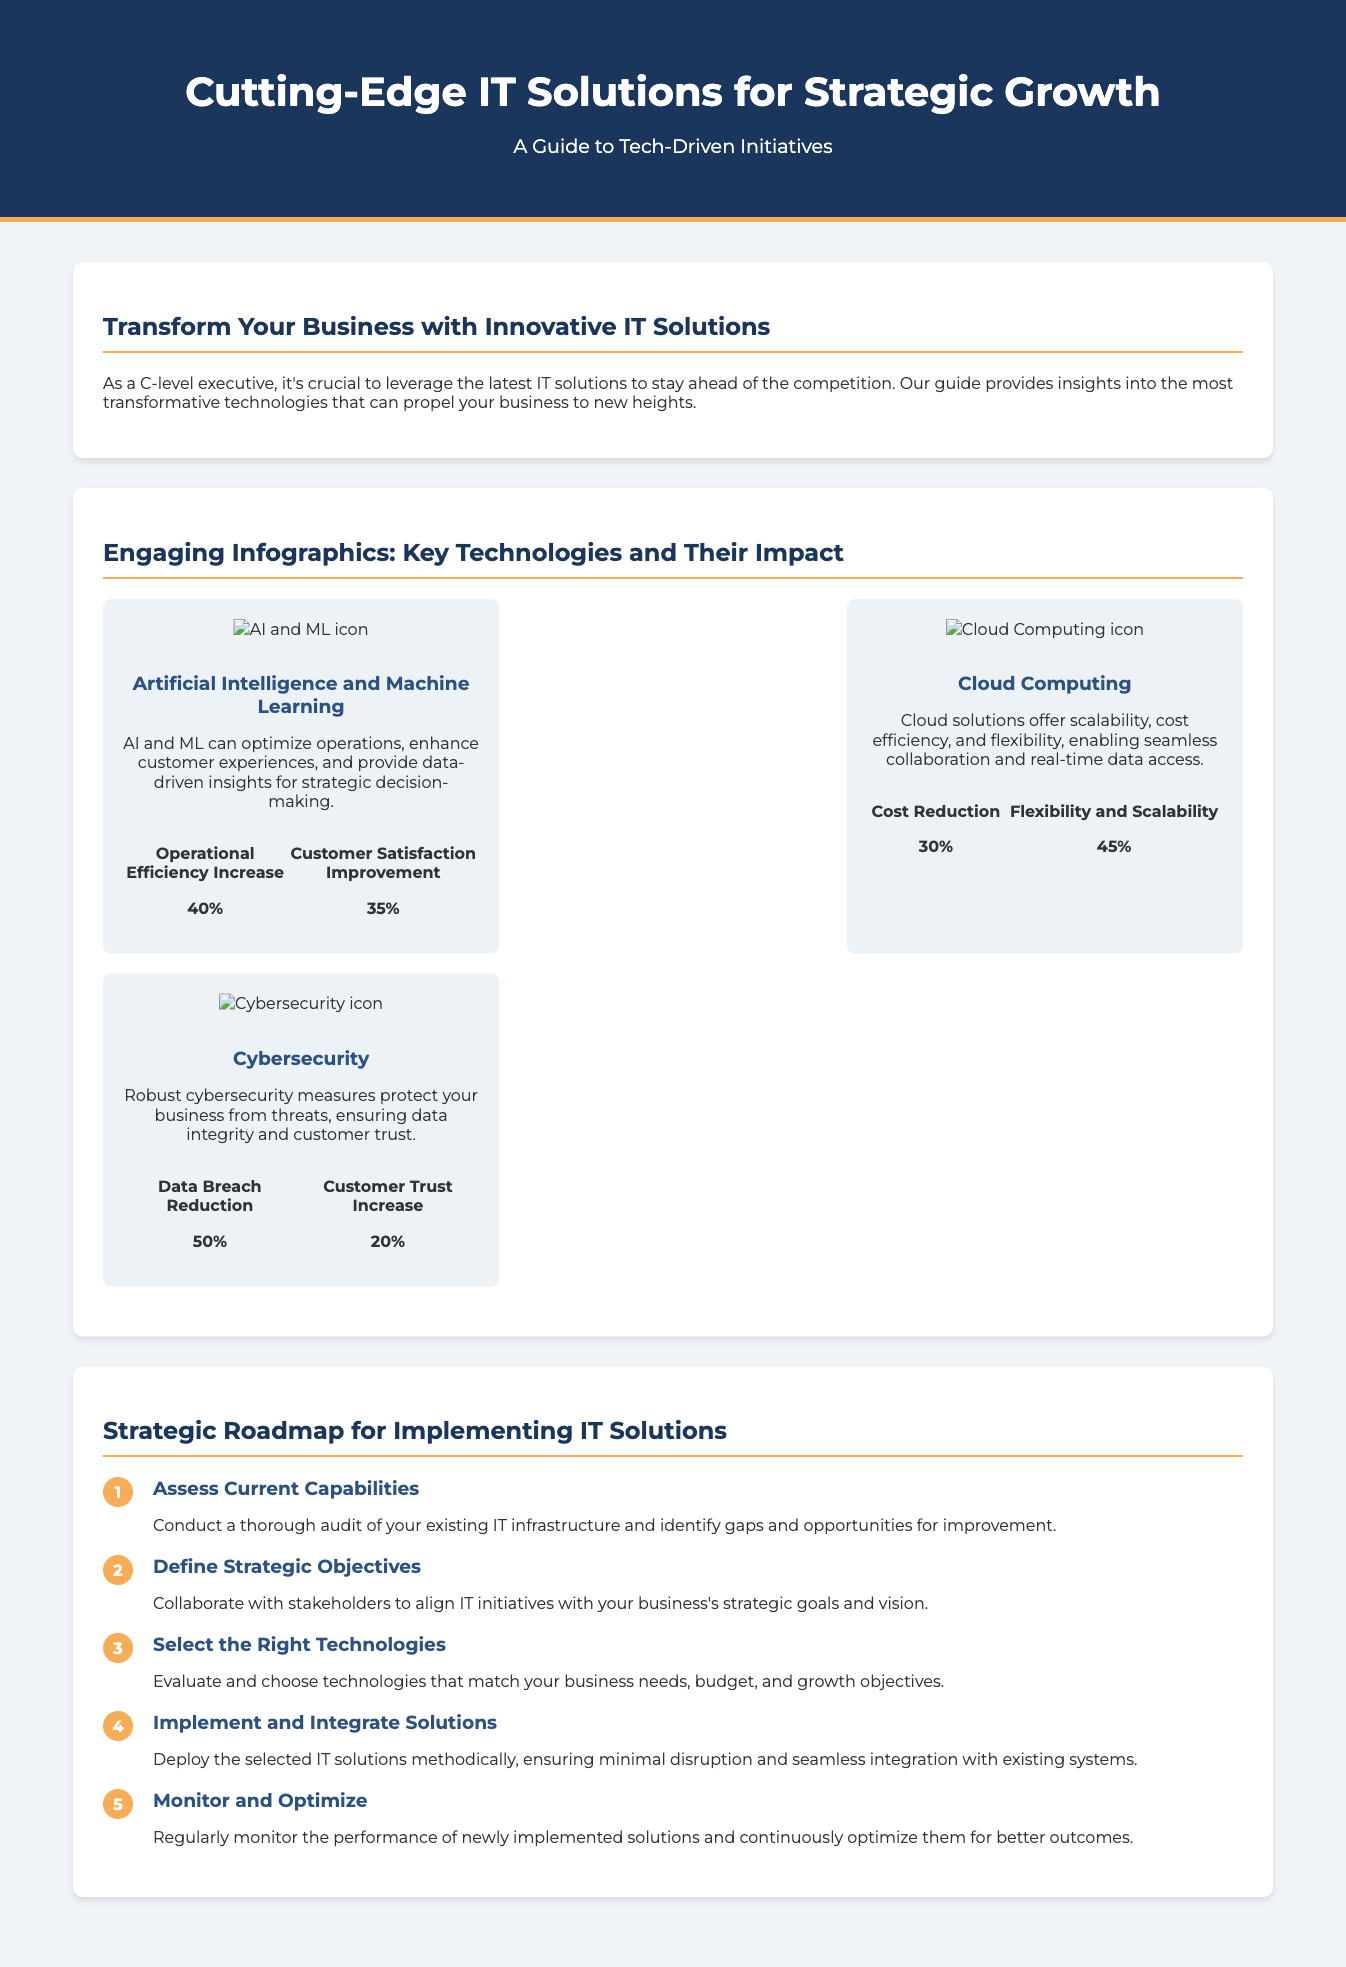what is the title of the document? The title of the document is prominently displayed in the header section.
Answer: Cutting-Edge IT Solutions for Strategic Growth what are the infographics about? The infographics provide key technologies and their impact on business growth, as detailed in the section heading.
Answer: Key Technologies and Their Impact how much can operational efficiency increase with AI and ML? The operational efficiency increase is specified in the statistics under the AI and ML infographic.
Answer: 40% what is the primary benefit of cloud computing according to the document? The document lists several benefits of cloud computing, but the primary one is highlighted in the infographic.
Answer: Scalability how many steps are in the strategic roadmap for implementing IT solutions? The roadmap section lists a sequence of steps in a numbered format, indicating how many steps are included.
Answer: Five steps what is the first step in the strategic roadmap? The first step is clearly outlined as part of the roadmap section.
Answer: Assess Current Capabilities which technology shows a 50% reduction in data breaches? The statistics associated with the infographic indicate which technology has this impact.
Answer: Cybersecurity what is the color of the header background? The background color is described in the CSS style, which reflects the document's visual elements.
Answer: Dark blue what is the main target audience described in the document? The document addresses a specific audience in its introductory sections, identifying the key reader group.
Answer: C-level executives 